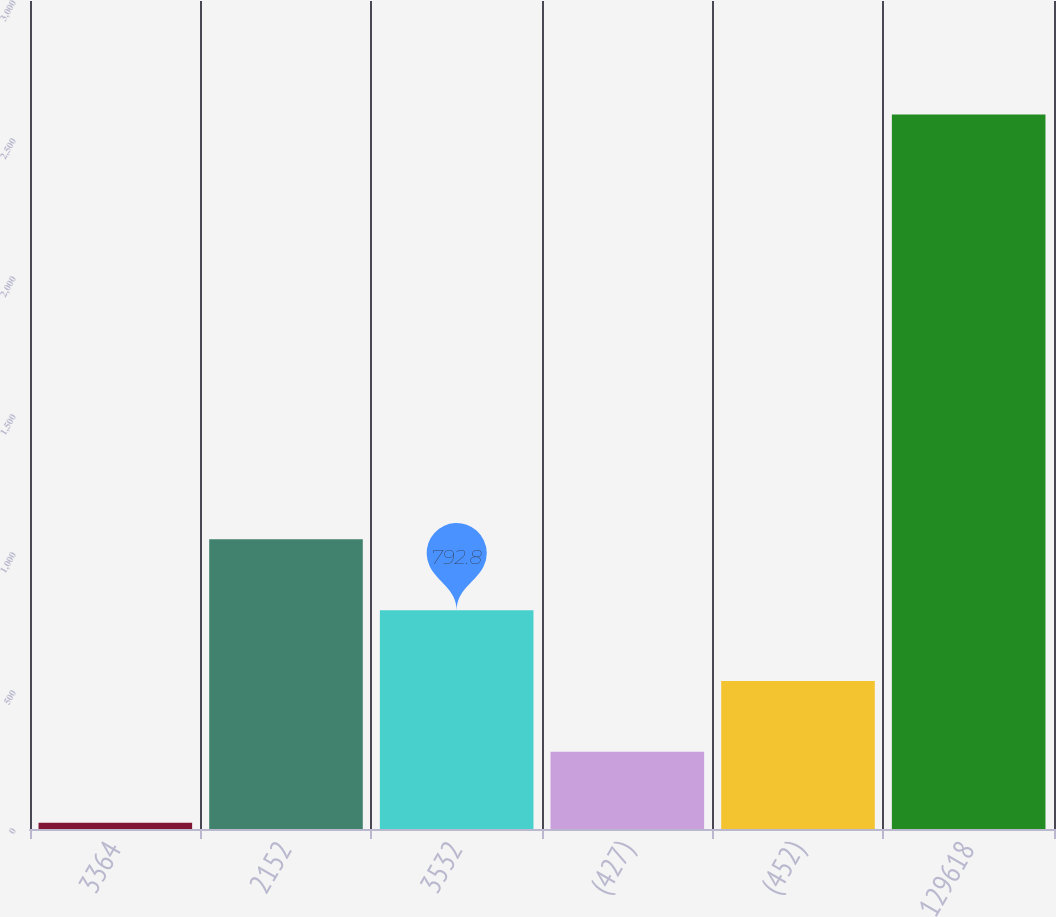Convert chart to OTSL. <chart><loc_0><loc_0><loc_500><loc_500><bar_chart><fcel>3364<fcel>2152<fcel>3532<fcel>(427)<fcel>(452)<fcel>129618<nl><fcel>23<fcel>1049.4<fcel>792.8<fcel>279.6<fcel>536.2<fcel>2589<nl></chart> 